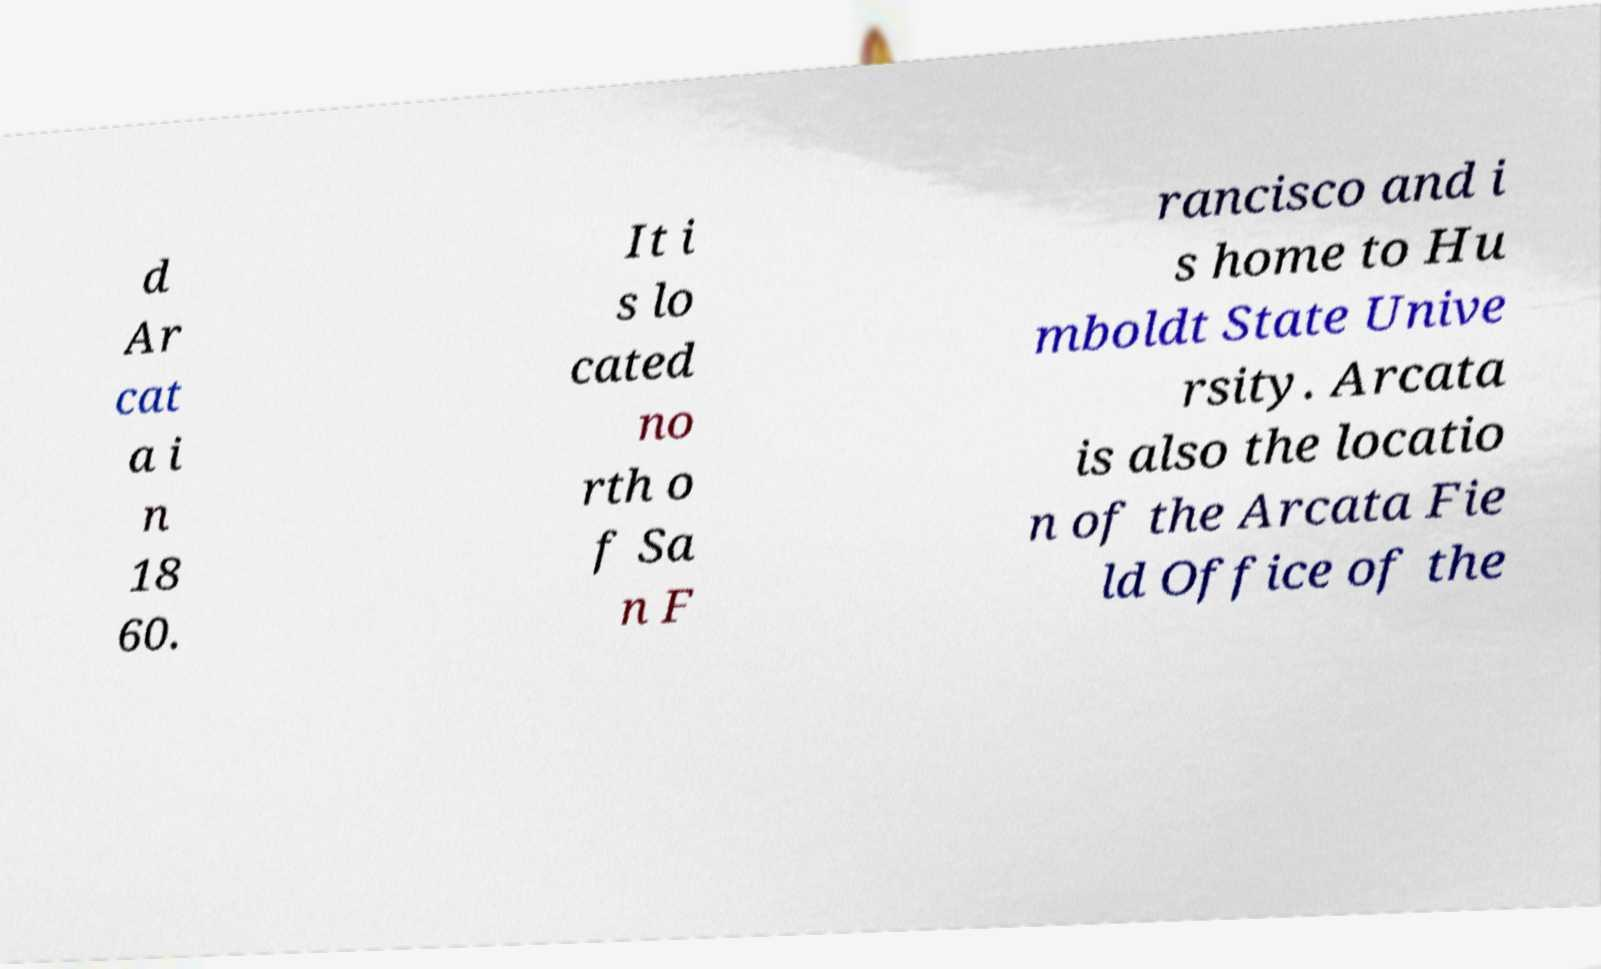What messages or text are displayed in this image? I need them in a readable, typed format. d Ar cat a i n 18 60. It i s lo cated no rth o f Sa n F rancisco and i s home to Hu mboldt State Unive rsity. Arcata is also the locatio n of the Arcata Fie ld Office of the 